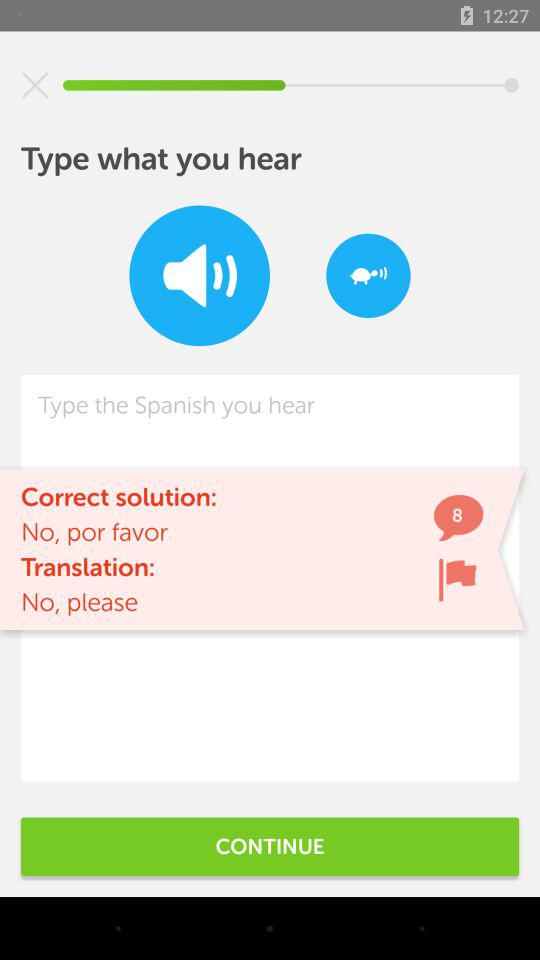How many suggestions are there? There are 8 suggestions. 